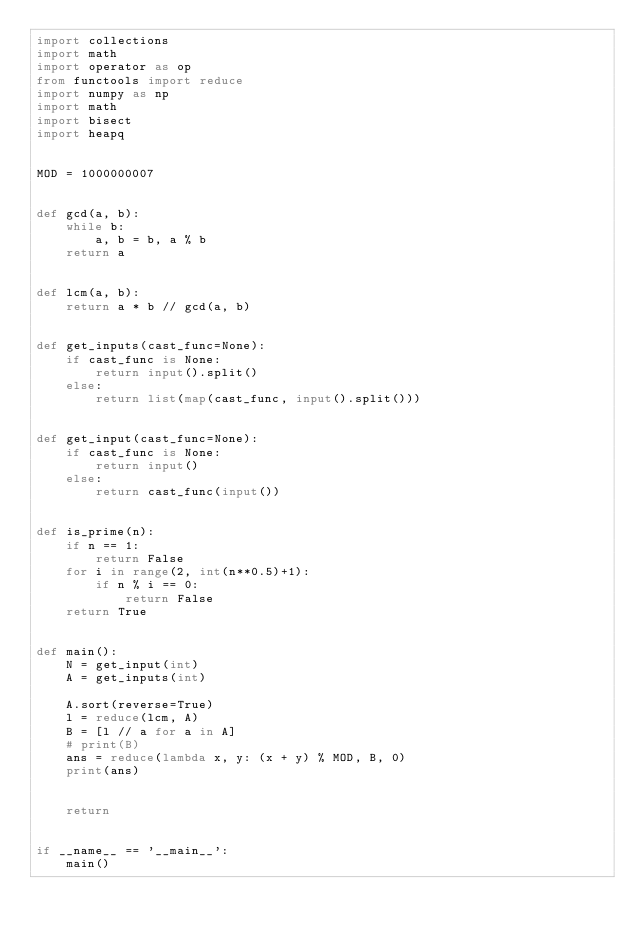<code> <loc_0><loc_0><loc_500><loc_500><_Python_>import collections
import math
import operator as op
from functools import reduce
import numpy as np
import math
import bisect
import heapq


MOD = 1000000007


def gcd(a, b):
    while b:
        a, b = b, a % b
    return a


def lcm(a, b):
    return a * b // gcd(a, b)


def get_inputs(cast_func=None):
    if cast_func is None:
        return input().split()
    else:
        return list(map(cast_func, input().split()))


def get_input(cast_func=None):
    if cast_func is None:
        return input()
    else:
        return cast_func(input())


def is_prime(n):
    if n == 1:
        return False
    for i in range(2, int(n**0.5)+1):
        if n % i == 0:
            return False
    return True


def main():
    N = get_input(int)
    A = get_inputs(int)

    A.sort(reverse=True)
    l = reduce(lcm, A)
    B = [l // a for a in A]
    # print(B)
    ans = reduce(lambda x, y: (x + y) % MOD, B, 0)
    print(ans)


    return


if __name__ == '__main__':
    main()
</code> 